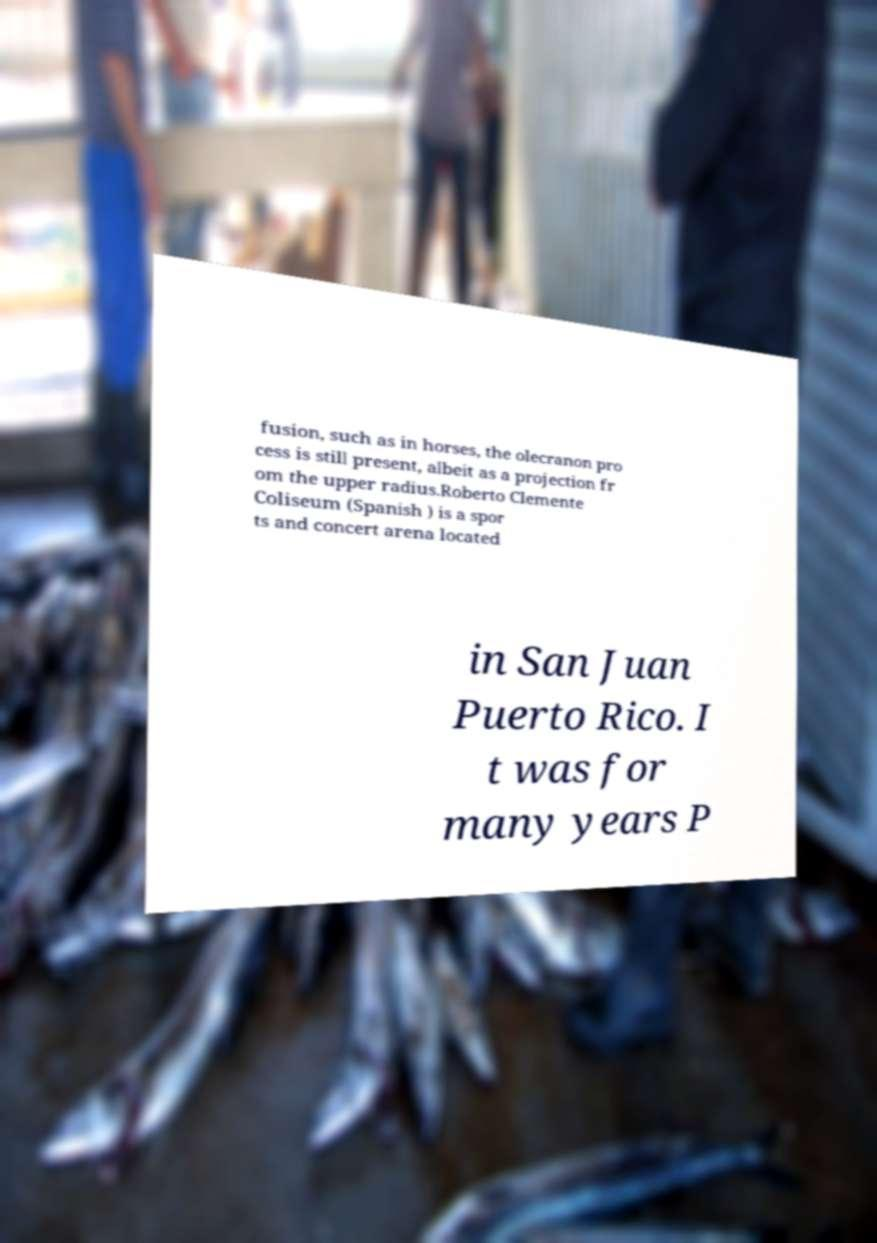I need the written content from this picture converted into text. Can you do that? fusion, such as in horses, the olecranon pro cess is still present, albeit as a projection fr om the upper radius.Roberto Clemente Coliseum (Spanish ) is a spor ts and concert arena located in San Juan Puerto Rico. I t was for many years P 